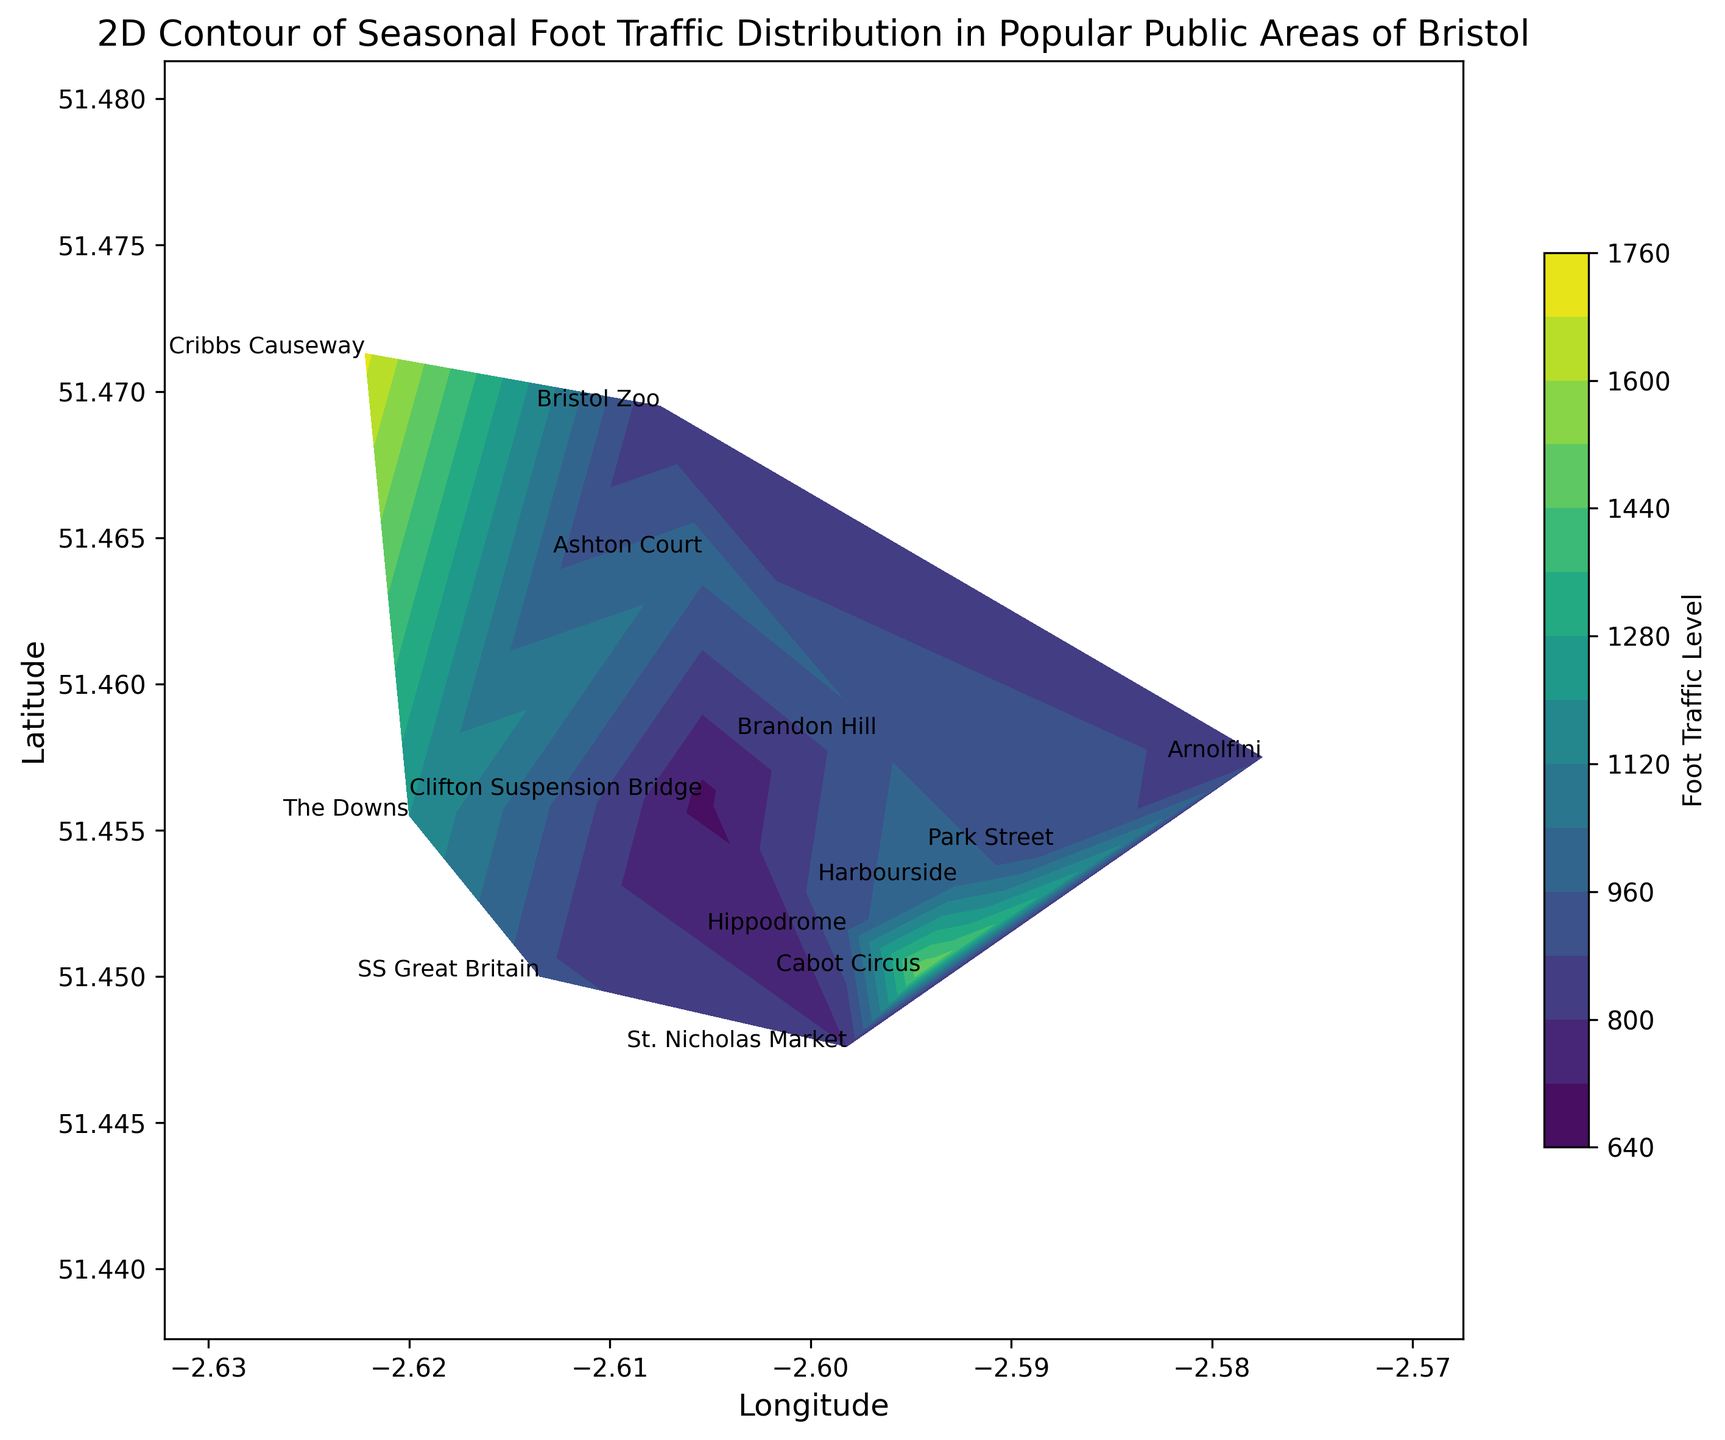What's the highest foot traffic observed during the summer season, and at which location? First, look at the color-coded contour for the summer season and locate the darkest or most intense color, which represents the highest foot traffic. Then, find the corresponding label for that location.
Answer: Cabot Circus, 1800 In which season does St. Nicholas Market see the least foot traffic, and what's the value? Locate St. Nicholas Market on the contour plot and compare the foot traffic levels in different seasons by observing the color intensities. The least intense color will indicate the lowest foot traffic.
Answer: Winter, 600 Compare the foot traffic at Bristol Zoo in spring and autumn. Which season has higher foot traffic and by how much? Find the contour lines or color intensities for Bristol Zoo in spring and autumn. Compare the values and calculate the difference.
Answer: Autumn, by 300 Is there a location that has consistently high foot traffic (above 1000) across all seasons? If so, name the location. Examine each location's foot traffic values for all four seasons. A location with all values above 1000 qualifies.
Answer: Cabot Circus Which season shows the least variation in foot traffic levels across all locations? Calculate the range (difference between the highest and lowest values) of foot traffic for each season and compare.
Answer: Winter Between The Downs and Arnolfini, which location has a higher foot traffic in spring, and by how much? Compare the foot traffic values for The Downs and Arnolfini in spring. Subtract the lower value from the higher value to find the difference.
Answer: The Downs, by 350 During which season is the foot traffic at Harbourside the lowest, and what is the value? Identify the foot traffic values for Harbourside in all four seasons and identify the minimum value.
Answer: Winter, 500 